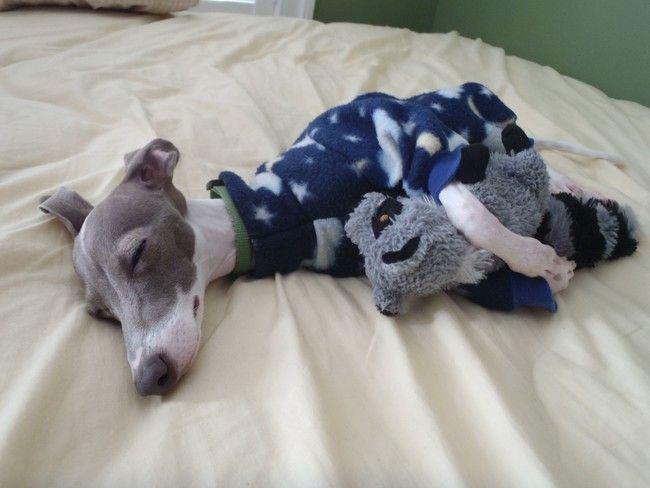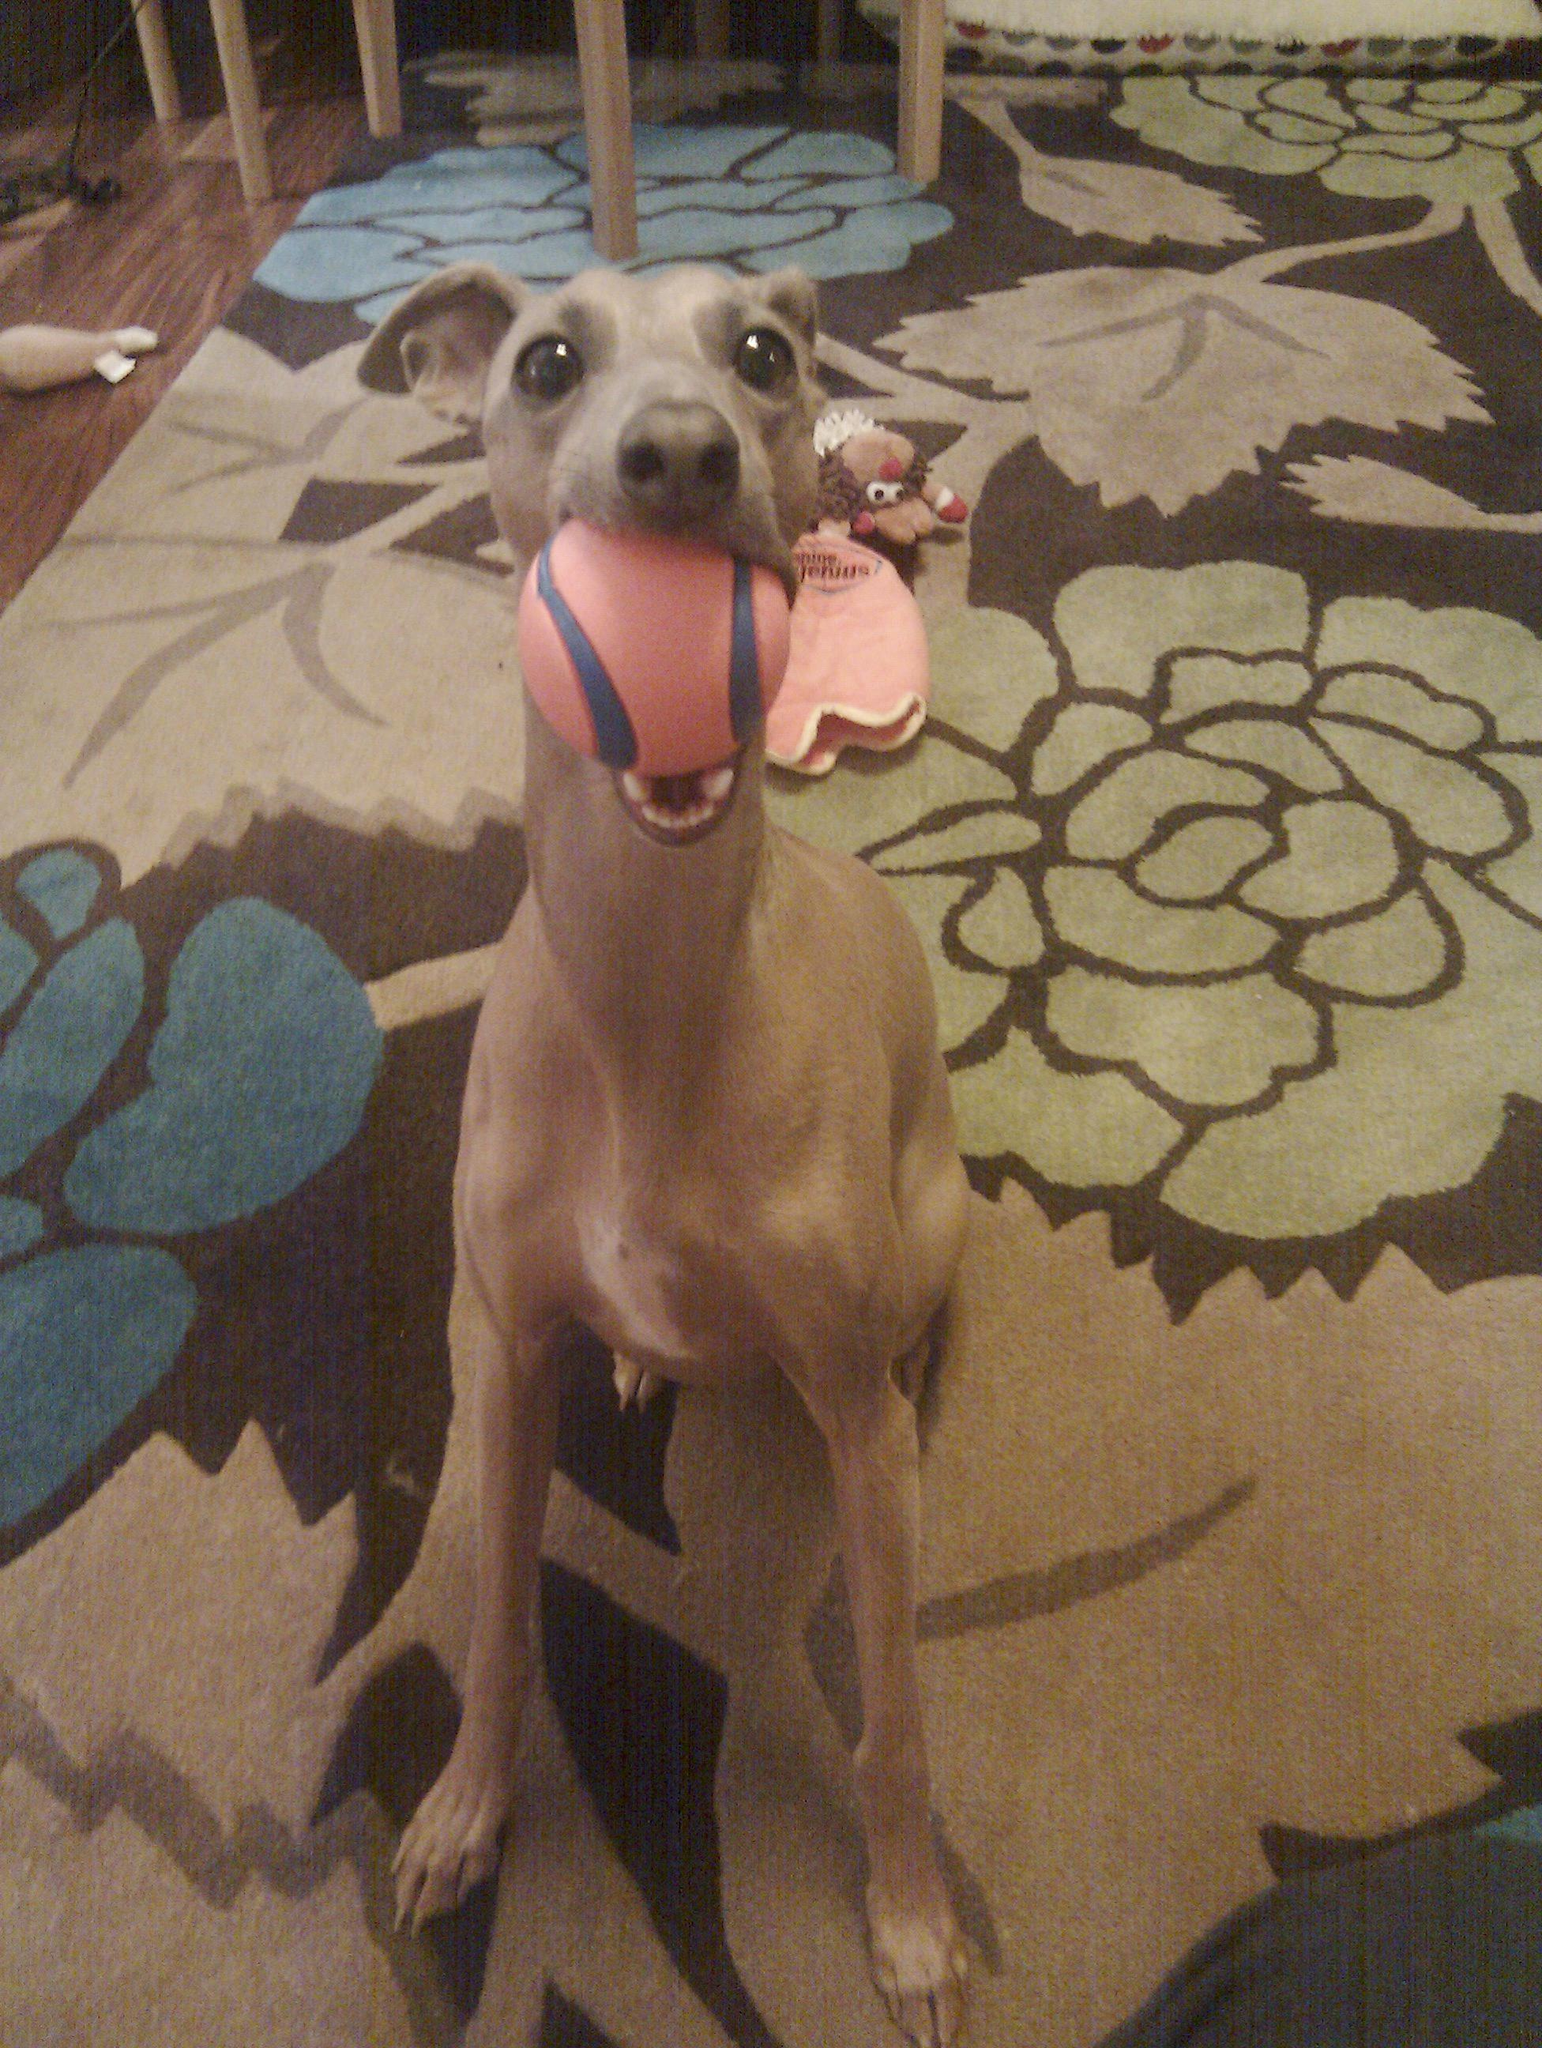The first image is the image on the left, the second image is the image on the right. Examine the images to the left and right. Is the description "All dogs are sleeping." accurate? Answer yes or no. No. The first image is the image on the left, the second image is the image on the right. Analyze the images presented: Is the assertion "One of the images shows a brown dog with a ball in its mouth." valid? Answer yes or no. Yes. 